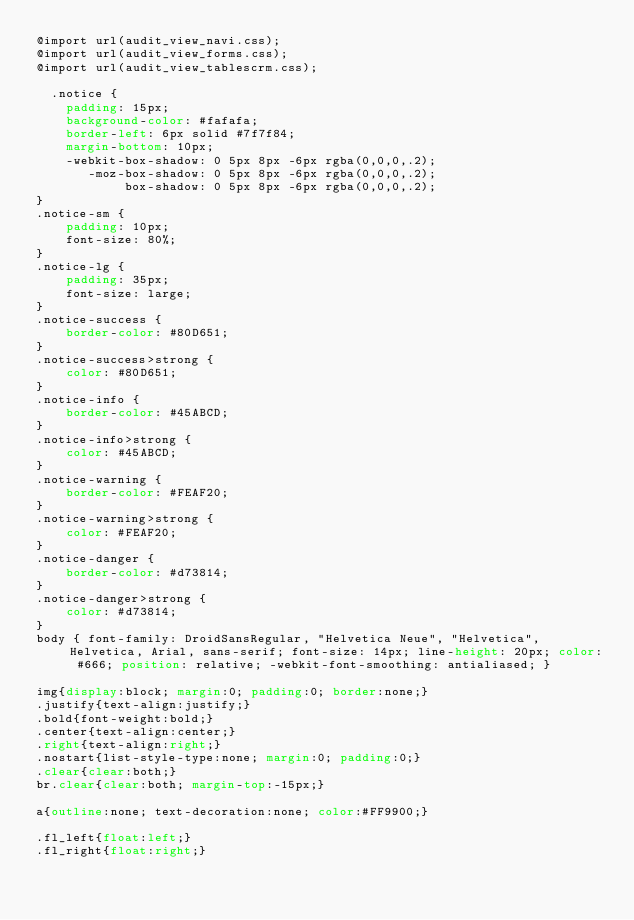Convert code to text. <code><loc_0><loc_0><loc_500><loc_500><_CSS_>@import url(audit_view_navi.css);
@import url(audit_view_forms.css);
@import url(audit_view_tablescrm.css);

	.notice {
    padding: 15px;
    background-color: #fafafa;
    border-left: 6px solid #7f7f84;
    margin-bottom: 10px;
    -webkit-box-shadow: 0 5px 8px -6px rgba(0,0,0,.2);
       -moz-box-shadow: 0 5px 8px -6px rgba(0,0,0,.2);
            box-shadow: 0 5px 8px -6px rgba(0,0,0,.2);
}
.notice-sm {
    padding: 10px;
    font-size: 80%;
}
.notice-lg {
    padding: 35px;
    font-size: large;
}
.notice-success {
    border-color: #80D651;
}
.notice-success>strong {
    color: #80D651;
}
.notice-info {
    border-color: #45ABCD;
}
.notice-info>strong {
    color: #45ABCD;
}
.notice-warning {
    border-color: #FEAF20;
}
.notice-warning>strong {
    color: #FEAF20;
}
.notice-danger {
    border-color: #d73814;
}
.notice-danger>strong {
    color: #d73814;
}
body { font-family: DroidSansRegular, "Helvetica Neue", "Helvetica", Helvetica, Arial, sans-serif; font-size: 14px; line-height: 20px; color: #666; position: relative; -webkit-font-smoothing: antialiased; }

img{display:block; margin:0; padding:0; border:none;}
.justify{text-align:justify;}
.bold{font-weight:bold;}
.center{text-align:center;}
.right{text-align:right;}
.nostart{list-style-type:none; margin:0; padding:0;}
.clear{clear:both;}
br.clear{clear:both; margin-top:-15px;}

a{outline:none; text-decoration:none; color:#FF9900;}

.fl_left{float:left;}
.fl_right{float:right;}

</code> 